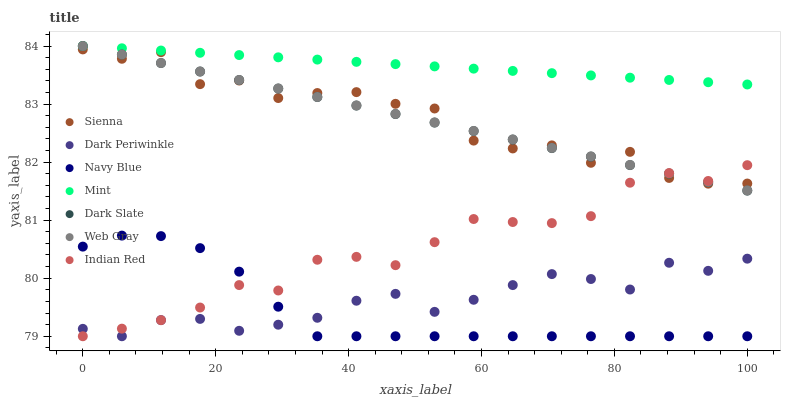Does Navy Blue have the minimum area under the curve?
Answer yes or no. Yes. Does Mint have the maximum area under the curve?
Answer yes or no. Yes. Does Sienna have the minimum area under the curve?
Answer yes or no. No. Does Sienna have the maximum area under the curve?
Answer yes or no. No. Is Mint the smoothest?
Answer yes or no. Yes. Is Sienna the roughest?
Answer yes or no. Yes. Is Navy Blue the smoothest?
Answer yes or no. No. Is Navy Blue the roughest?
Answer yes or no. No. Does Navy Blue have the lowest value?
Answer yes or no. Yes. Does Sienna have the lowest value?
Answer yes or no. No. Does Mint have the highest value?
Answer yes or no. Yes. Does Navy Blue have the highest value?
Answer yes or no. No. Is Navy Blue less than Web Gray?
Answer yes or no. Yes. Is Dark Slate greater than Navy Blue?
Answer yes or no. Yes. Does Indian Red intersect Dark Periwinkle?
Answer yes or no. Yes. Is Indian Red less than Dark Periwinkle?
Answer yes or no. No. Is Indian Red greater than Dark Periwinkle?
Answer yes or no. No. Does Navy Blue intersect Web Gray?
Answer yes or no. No. 